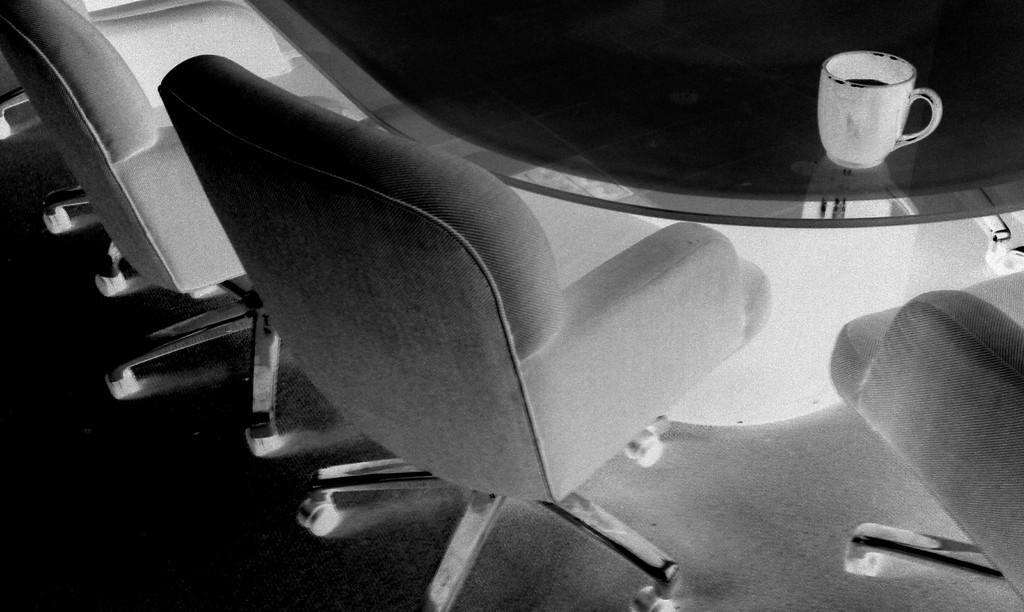Describe this image in one or two sentences. This is the black and white image where we can see chairs on the floor and a cup with a drink in it is placed on the table. 